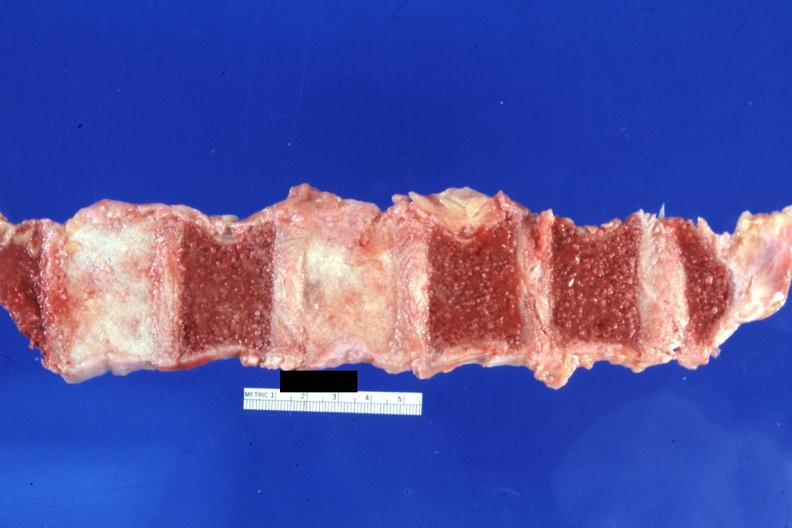what assumed?
Answer the question using a single word or phrase. Cut surface typical ivory vertebra do not have history at this time diagnosis 